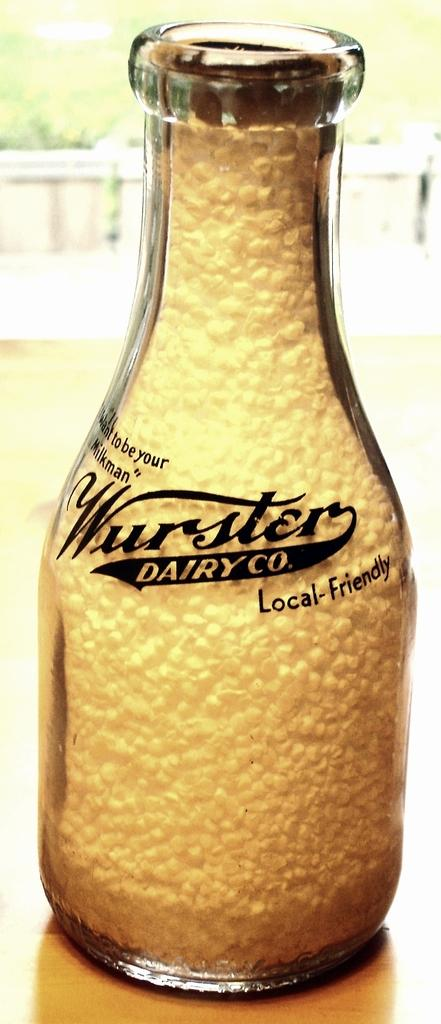<image>
Create a compact narrative representing the image presented. Bottle saying "Wurster Dairy Co" on it and is local-friendly. 